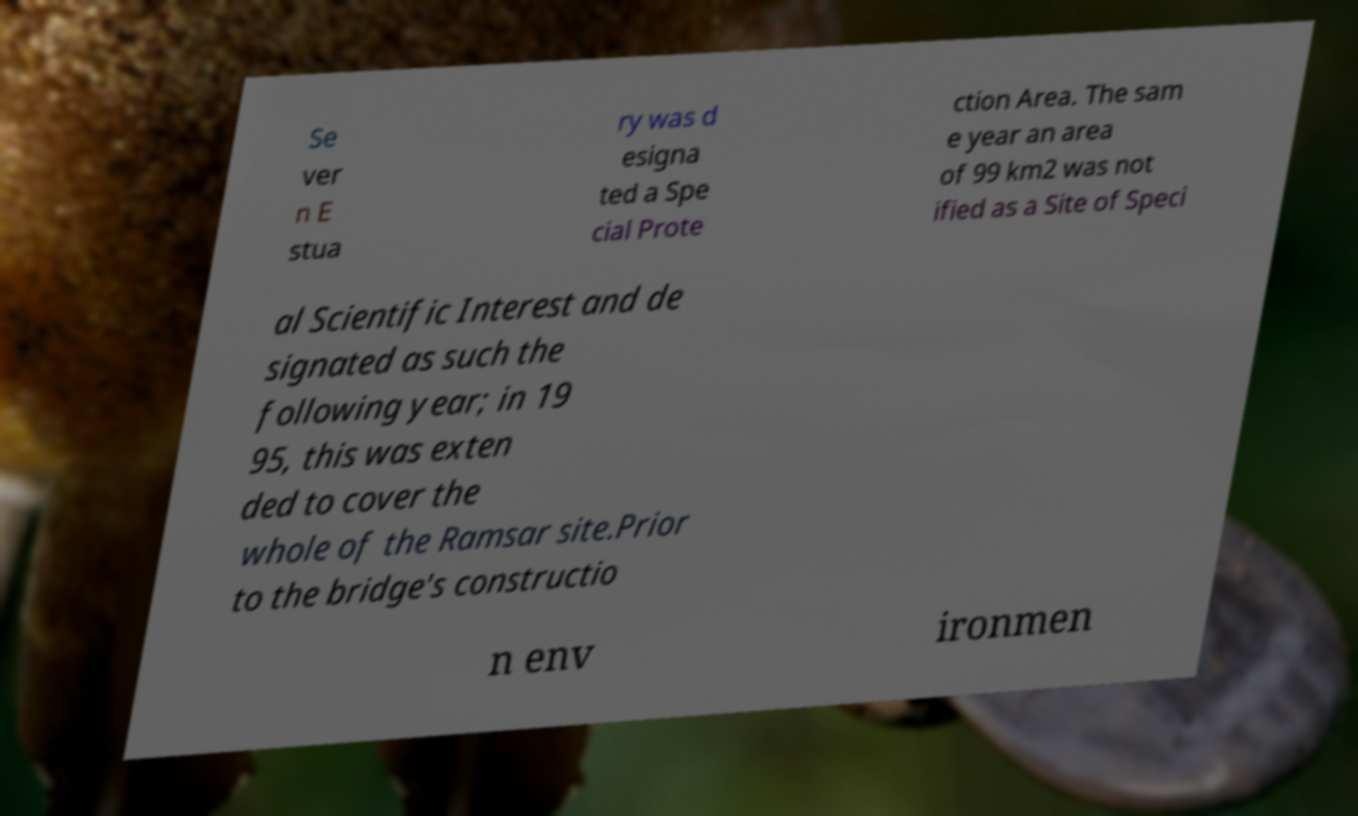Could you extract and type out the text from this image? Se ver n E stua ry was d esigna ted a Spe cial Prote ction Area. The sam e year an area of 99 km2 was not ified as a Site of Speci al Scientific Interest and de signated as such the following year; in 19 95, this was exten ded to cover the whole of the Ramsar site.Prior to the bridge's constructio n env ironmen 